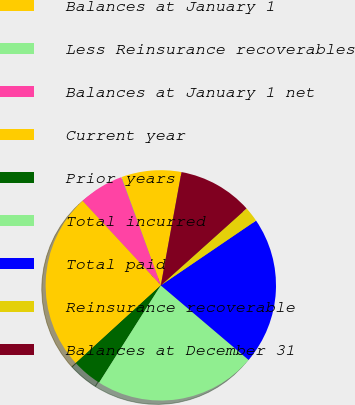<chart> <loc_0><loc_0><loc_500><loc_500><pie_chart><fcel>Balances at January 1<fcel>Less Reinsurance recoverables<fcel>Balances at January 1 net<fcel>Current year<fcel>Prior years<fcel>Total incurred<fcel>Total paid<fcel>Reinsurance recoverable<fcel>Balances at December 31<nl><fcel>8.4%<fcel>0.05%<fcel>6.31%<fcel>24.88%<fcel>4.22%<fcel>22.79%<fcel>20.7%<fcel>2.13%<fcel>10.49%<nl></chart> 